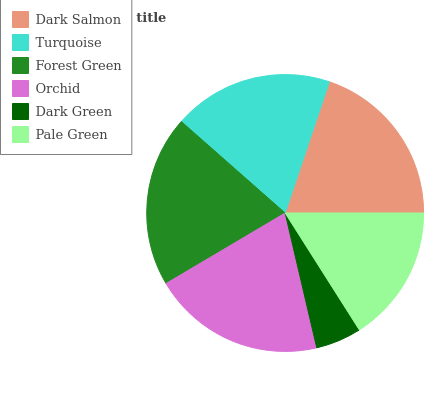Is Dark Green the minimum?
Answer yes or no. Yes. Is Orchid the maximum?
Answer yes or no. Yes. Is Turquoise the minimum?
Answer yes or no. No. Is Turquoise the maximum?
Answer yes or no. No. Is Dark Salmon greater than Turquoise?
Answer yes or no. Yes. Is Turquoise less than Dark Salmon?
Answer yes or no. Yes. Is Turquoise greater than Dark Salmon?
Answer yes or no. No. Is Dark Salmon less than Turquoise?
Answer yes or no. No. Is Dark Salmon the high median?
Answer yes or no. Yes. Is Turquoise the low median?
Answer yes or no. Yes. Is Pale Green the high median?
Answer yes or no. No. Is Forest Green the low median?
Answer yes or no. No. 